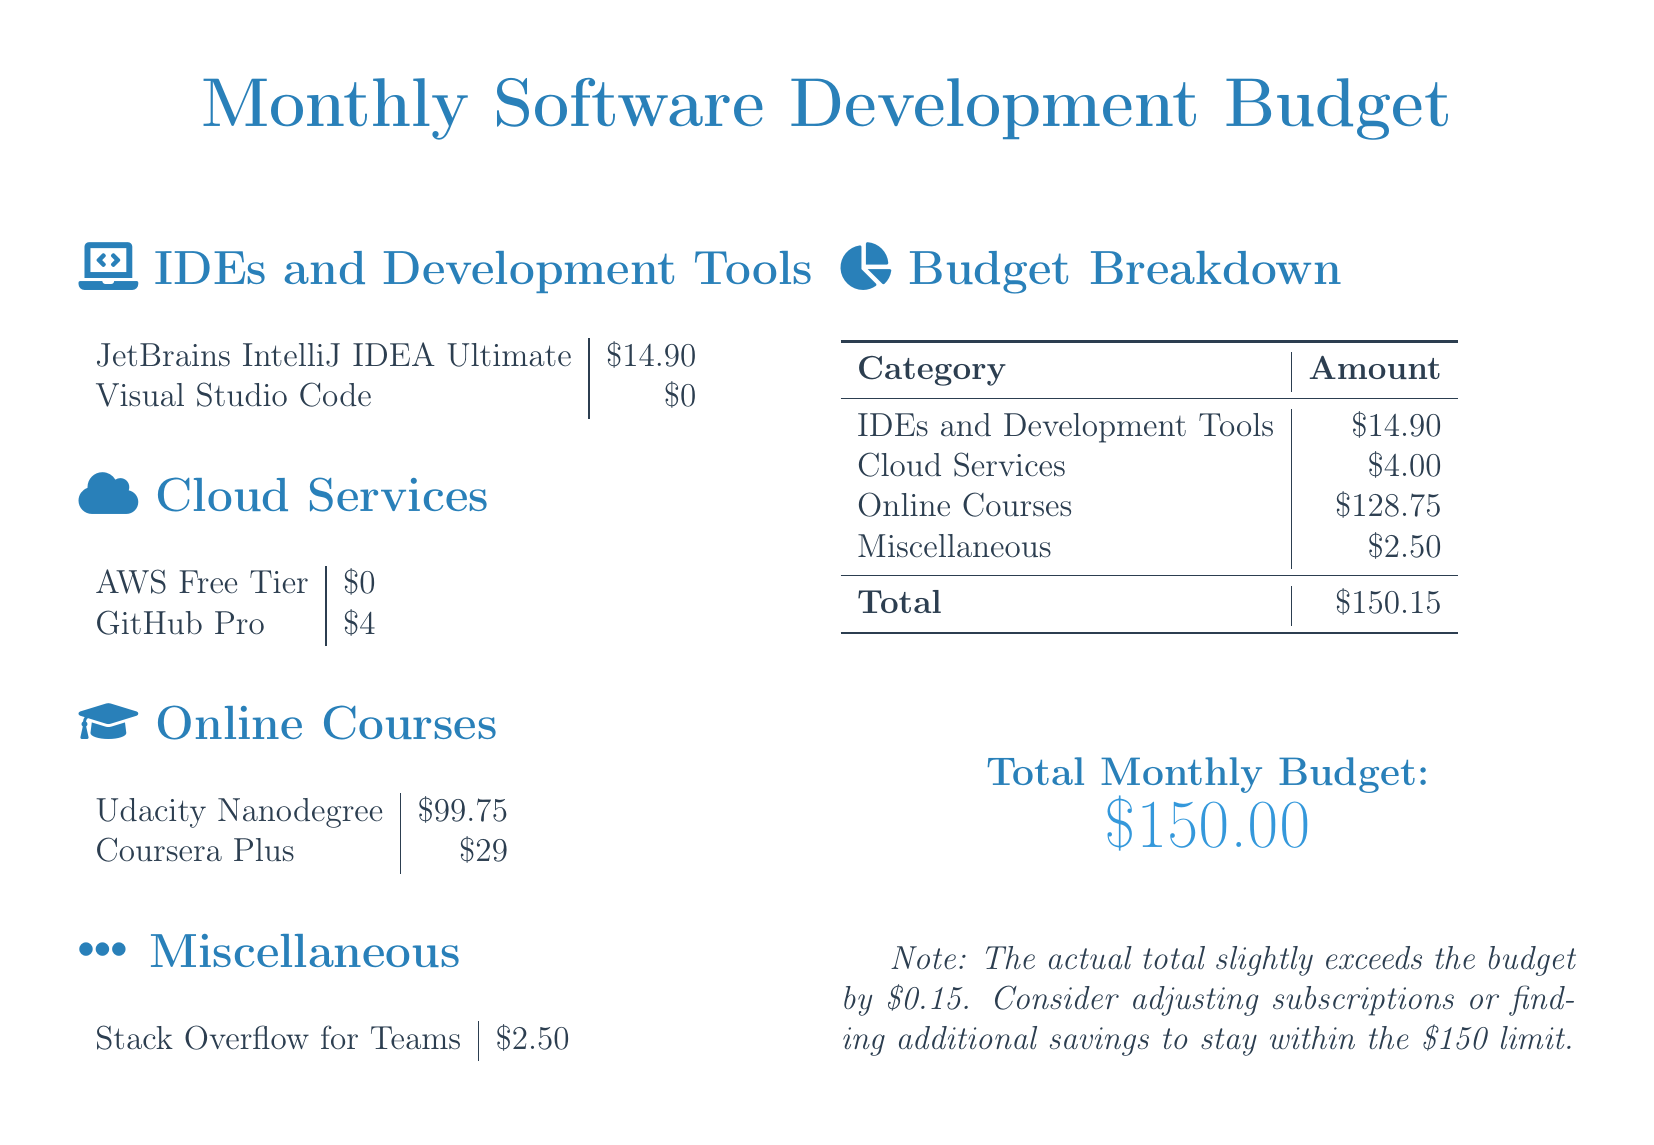What is the total budget? The total budget is stated at the end of the document.
Answer: $150.00 How much is spent on IDEs and Development Tools? This amount is listed in the budget breakdown section.
Answer: $14.90 What is the cost of GitHub Pro? The cost of GitHub Pro is provided in the Cloud Services section.
Answer: $4 What is the price of the Udacity Nanodegree? This price appears in the Online Courses section.
Answer: $99.75 Which IDE is free? The document indicates which IDE has no cost.
Answer: Visual Studio Code What is the total amount spent on Online Courses? This total comes from adding up the online course expenses in the budget breakdown.
Answer: $128.75 How much is Stack Overflow for Teams? The specific cost of Stack Overflow is stated in the Miscellaneous section.
Answer: $2.50 What is the excess amount over the budget? The document notes the difference between the total and the budget limit.
Answer: $0.15 How much is the AWS Free Tier? This amount is listed under Cloud Services in the budget.
Answer: $0 